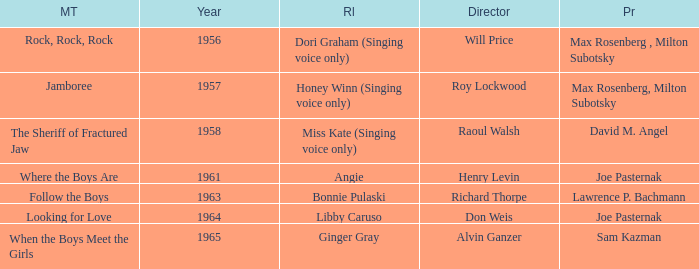What movie was made in 1957? Jamboree. 